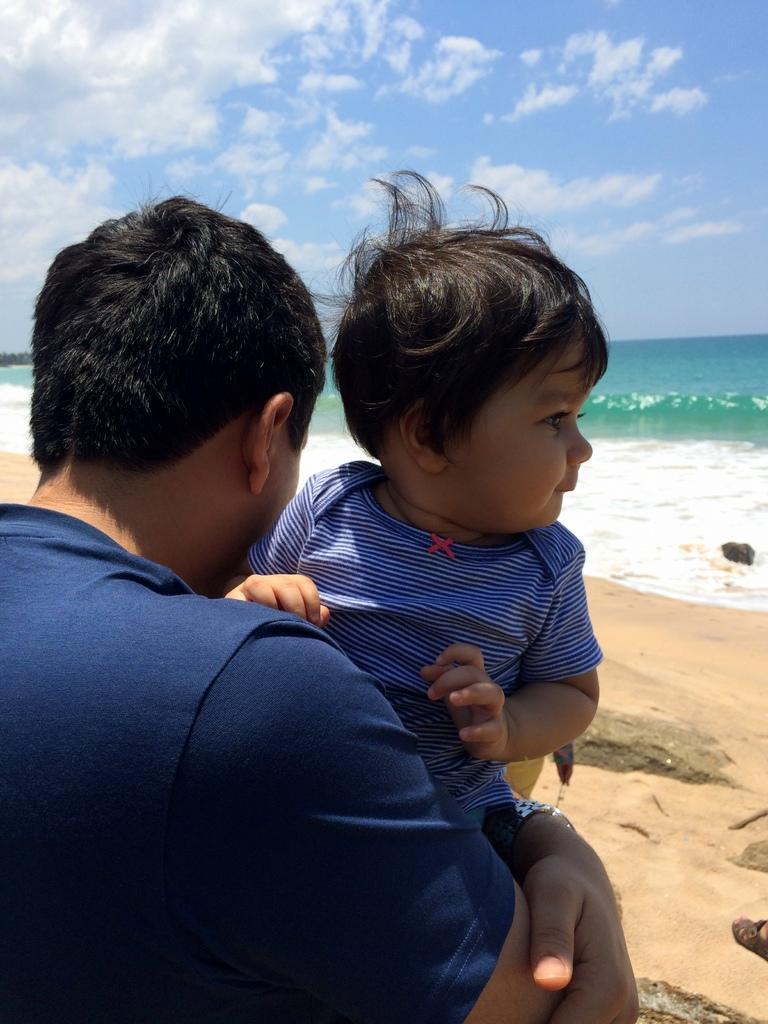Can you describe this image briefly? In this image, we can see a person wearing clothes and holding a baby with his hands. There is a sea in the middle of the image. There is a sky at the top of the image. 